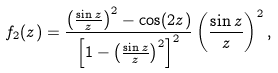Convert formula to latex. <formula><loc_0><loc_0><loc_500><loc_500>f _ { 2 } ( z ) = \frac { \left ( \frac { \sin z } { z } \right ) ^ { 2 } - \cos ( 2 z ) } { \left [ 1 - \left ( \frac { \sin z } { z } \right ) ^ { 2 } \right ] ^ { 2 } } \left ( \frac { \sin z } { z } \right ) ^ { 2 } ,</formula> 